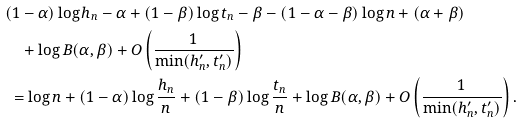Convert formula to latex. <formula><loc_0><loc_0><loc_500><loc_500>& ( 1 - \alpha ) \log h _ { n } - \alpha + ( 1 - \beta ) \log t _ { n } - \beta - ( 1 - \alpha - \beta ) \log n + ( \alpha + \beta ) \\ & \quad + \log B ( \alpha , \beta ) + O \left ( \frac { 1 } { \min ( h _ { n } ^ { \prime } , t _ { n } ^ { \prime } ) } \right ) \\ & \ = \log n + ( 1 - \alpha ) \log \frac { h _ { n } } { n } + ( 1 - \beta ) \log \frac { t _ { n } } { n } + \log B ( \alpha , \beta ) + O \left ( \frac { 1 } { \min ( h _ { n } ^ { \prime } , t _ { n } ^ { \prime } ) } \right ) .</formula> 